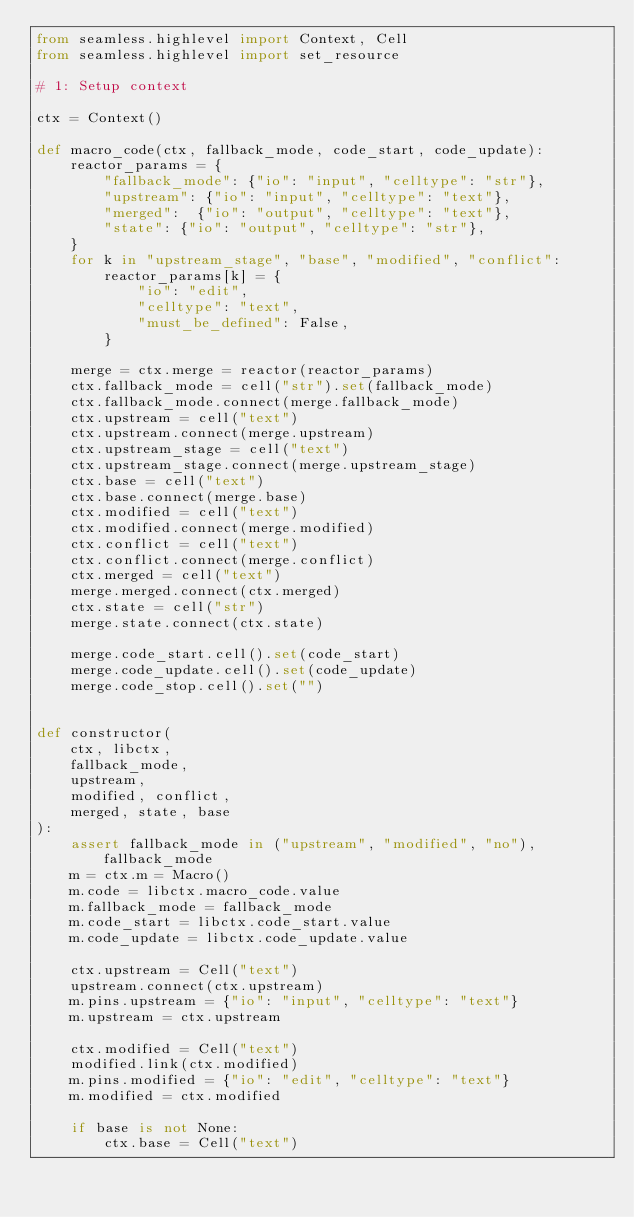<code> <loc_0><loc_0><loc_500><loc_500><_Python_>from seamless.highlevel import Context, Cell
from seamless.highlevel import set_resource

# 1: Setup context

ctx = Context()

def macro_code(ctx, fallback_mode, code_start, code_update):
    reactor_params = {
        "fallback_mode": {"io": "input", "celltype": "str"},
        "upstream": {"io": "input", "celltype": "text"},
        "merged":  {"io": "output", "celltype": "text"},
        "state": {"io": "output", "celltype": "str"},
    }
    for k in "upstream_stage", "base", "modified", "conflict":
        reactor_params[k] = {
            "io": "edit",
            "celltype": "text",
            "must_be_defined": False,
        }

    merge = ctx.merge = reactor(reactor_params)
    ctx.fallback_mode = cell("str").set(fallback_mode)
    ctx.fallback_mode.connect(merge.fallback_mode)
    ctx.upstream = cell("text")
    ctx.upstream.connect(merge.upstream)
    ctx.upstream_stage = cell("text")
    ctx.upstream_stage.connect(merge.upstream_stage)
    ctx.base = cell("text")
    ctx.base.connect(merge.base)
    ctx.modified = cell("text")
    ctx.modified.connect(merge.modified)
    ctx.conflict = cell("text")
    ctx.conflict.connect(merge.conflict)
    ctx.merged = cell("text")
    merge.merged.connect(ctx.merged)
    ctx.state = cell("str")
    merge.state.connect(ctx.state)

    merge.code_start.cell().set(code_start)
    merge.code_update.cell().set(code_update)
    merge.code_stop.cell().set("")


def constructor(
    ctx, libctx,
    fallback_mode,
    upstream,
    modified, conflict,
    merged, state, base
):
    assert fallback_mode in ("upstream", "modified", "no"), fallback_mode
    m = ctx.m = Macro()
    m.code = libctx.macro_code.value
    m.fallback_mode = fallback_mode
    m.code_start = libctx.code_start.value
    m.code_update = libctx.code_update.value

    ctx.upstream = Cell("text")
    upstream.connect(ctx.upstream)
    m.pins.upstream = {"io": "input", "celltype": "text"}
    m.upstream = ctx.upstream

    ctx.modified = Cell("text")
    modified.link(ctx.modified)
    m.pins.modified = {"io": "edit", "celltype": "text"}
    m.modified = ctx.modified

    if base is not None:
        ctx.base = Cell("text")</code> 